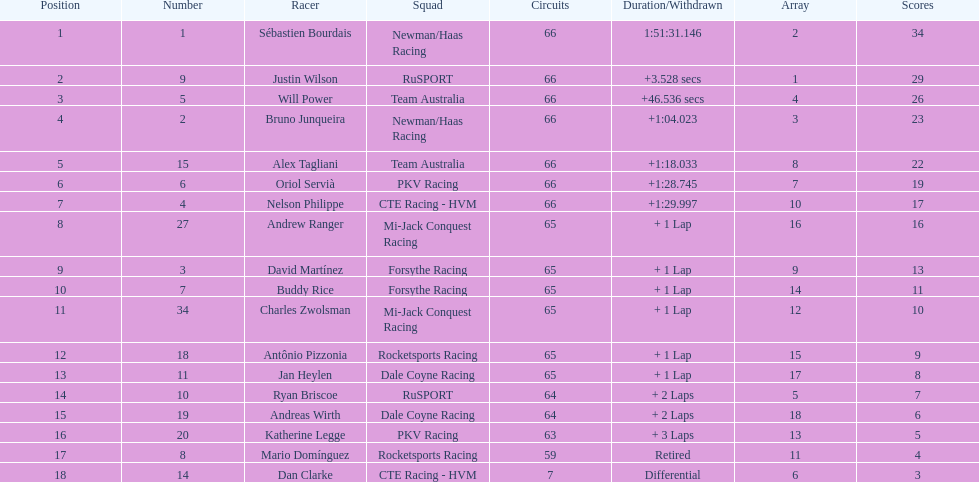How many drivers did not make more than 60 laps? 2. 